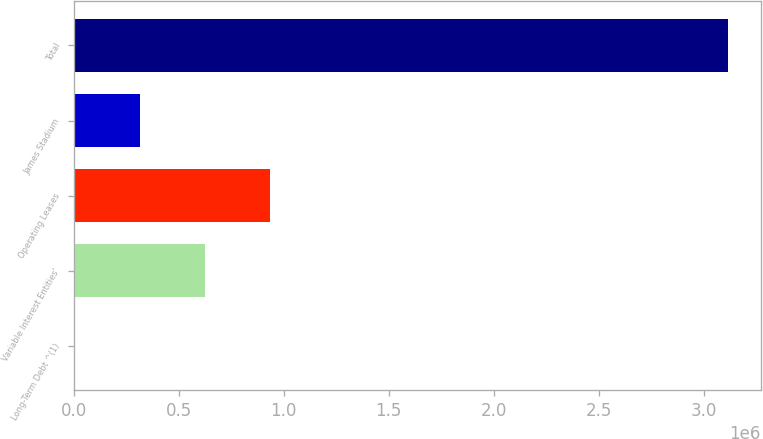<chart> <loc_0><loc_0><loc_500><loc_500><bar_chart><fcel>Long-Term Debt ^(1)<fcel>Variable Interest Entities'<fcel>Operating Leases<fcel>James Stadium<fcel>Total<nl><fcel>3075<fcel>625616<fcel>936886<fcel>314345<fcel>3.11578e+06<nl></chart> 